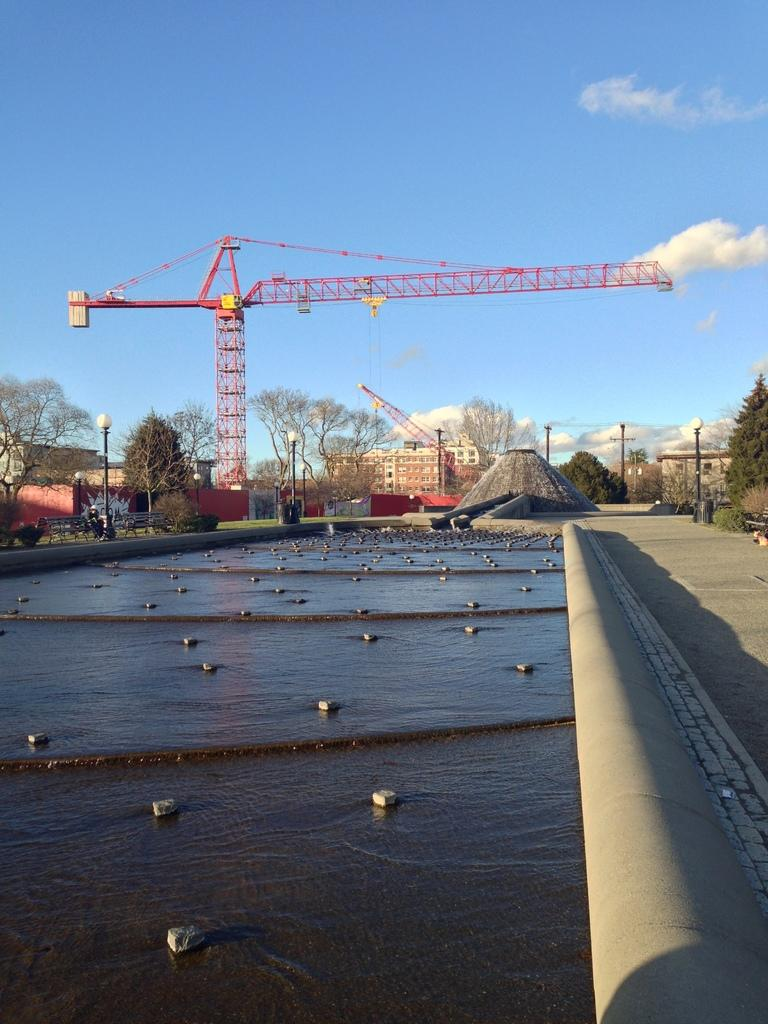What is the primary element visible in the image? There is water in the image. What structures can be seen in the image? There are poles and lights visible in the image. What can be seen in the background of the image? There are cranes, trees, houses, and clouds in the background of the image. What is the person in the image doing? There is a person seated on a bench in the image. What type of wilderness can be seen in the image? There is no wilderness present in the image; it features a person seated on a bench near water, with structures and background elements visible. 